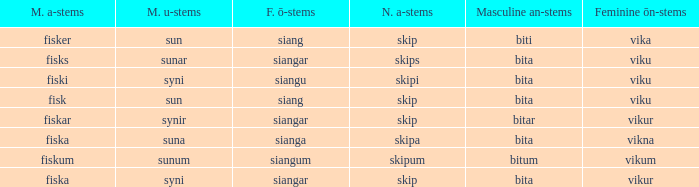What is the masculine u form for the old Swedish word with a neuter a form of skipum? Sunum. 